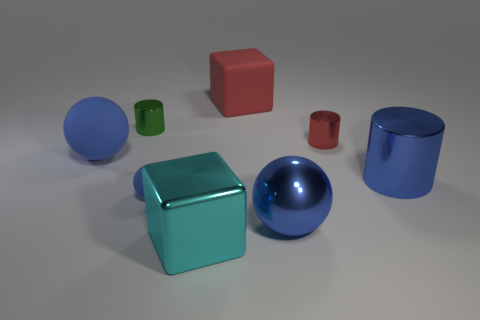What number of things are either red objects right of the red rubber cube or objects in front of the tiny red object?
Offer a terse response. 6. The red object that is the same material as the small green cylinder is what size?
Your answer should be very brief. Small. What number of metal things are small green cubes or small red things?
Make the answer very short. 1. The red metal thing is what size?
Ensure brevity in your answer.  Small. Does the cyan shiny object have the same size as the red matte thing?
Offer a very short reply. Yes. There is a cylinder that is in front of the red metal object; what is its material?
Your answer should be very brief. Metal. There is a red object that is the same shape as the big cyan thing; what material is it?
Your answer should be compact. Rubber. Are there any blue metallic things in front of the large rubber thing that is to the right of the shiny block?
Provide a short and direct response. Yes. Is the green metallic thing the same shape as the red metal thing?
Keep it short and to the point. Yes. There is a cyan object that is made of the same material as the small red cylinder; what is its shape?
Offer a terse response. Cube. 